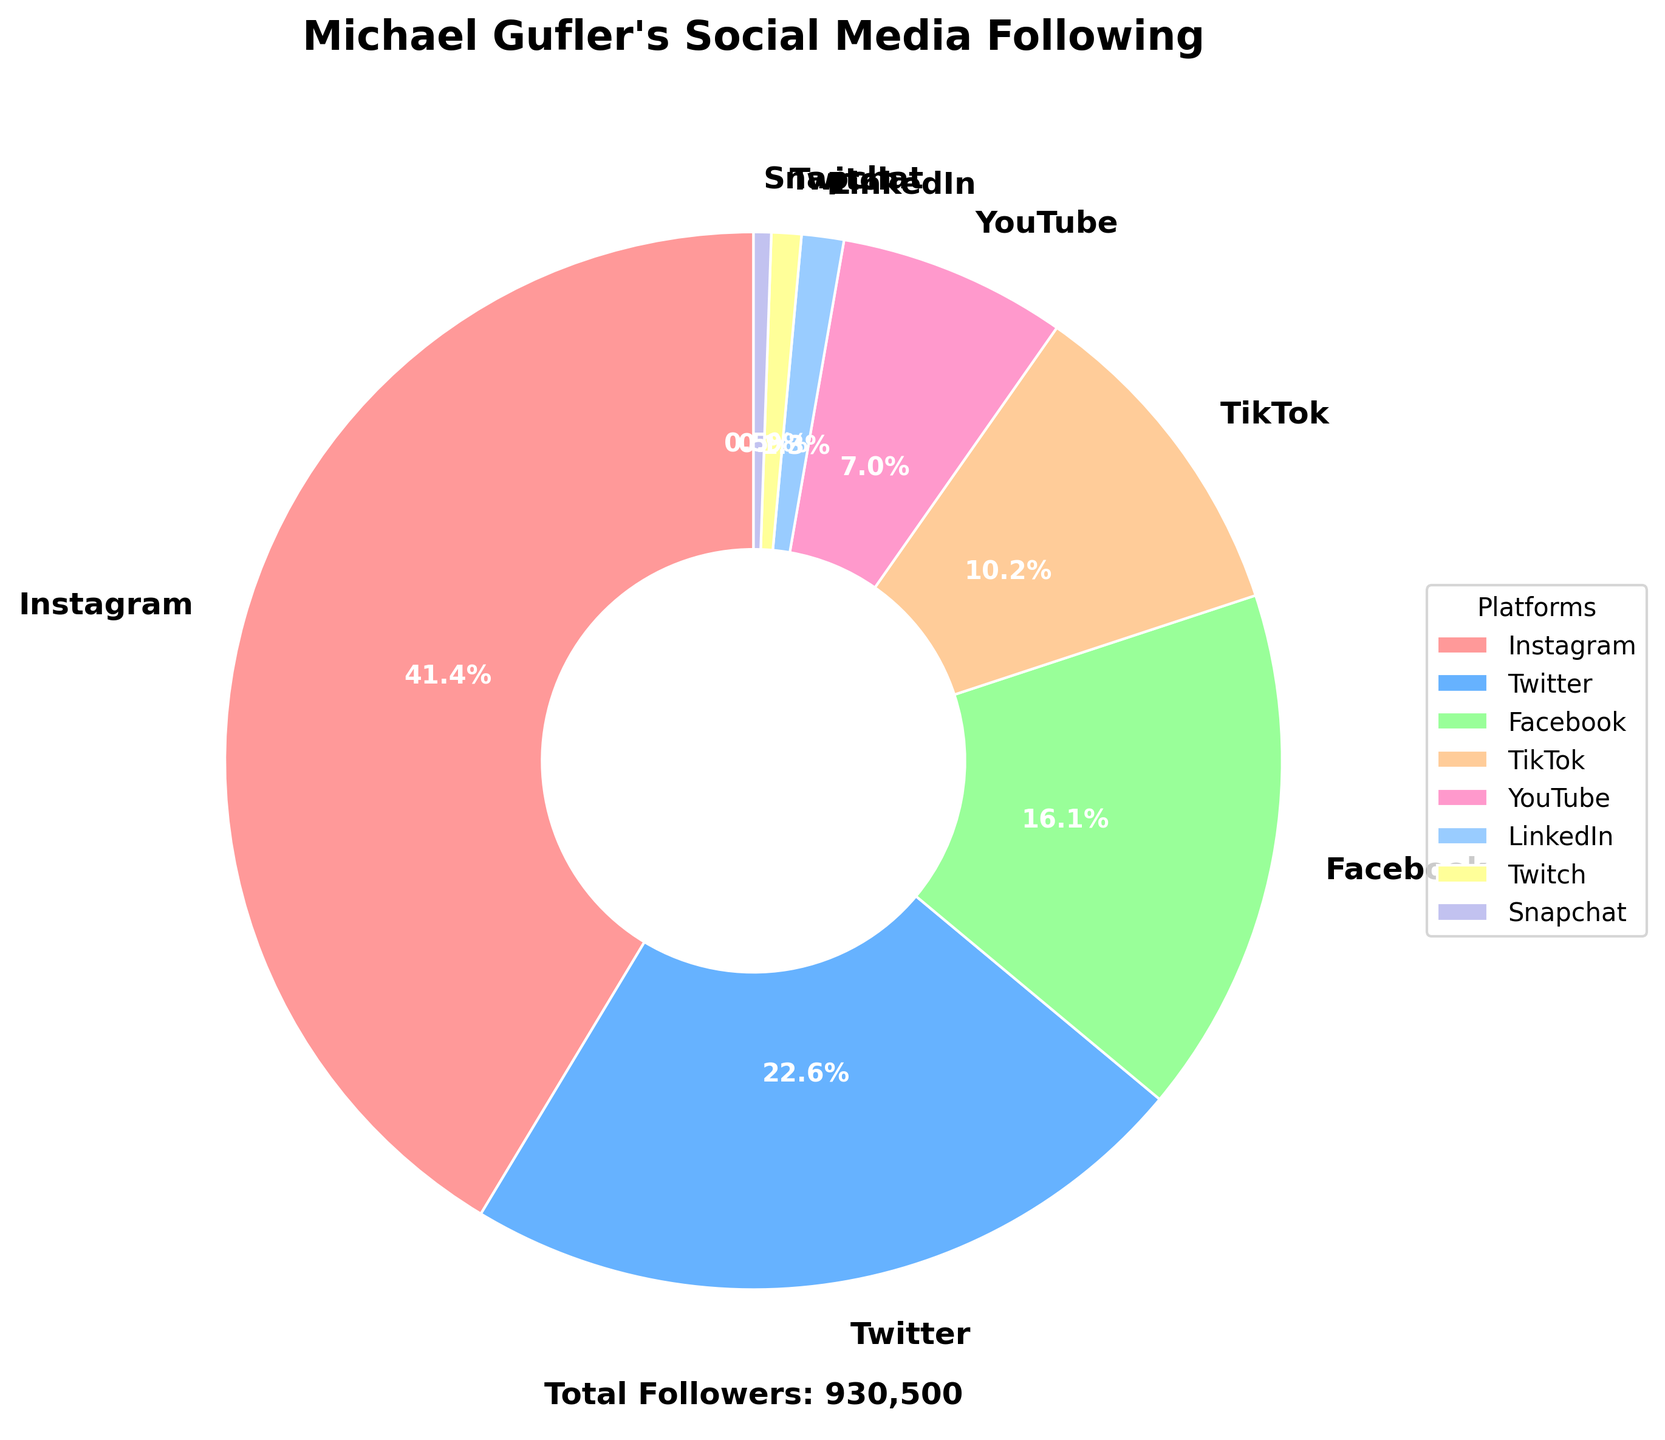Which platform has the highest number of followers? By looking at the pie chart, we can identify the platform with the largest wedge, which represents the highest number of followers. Instagram has the largest share.
Answer: Instagram What percentage of Michael Gufler's following is on TikTok? Find the wedge labeled 'TikTok' in the pie chart and read the percentage value provided inside or next to that wedge.
Answer: 11.4% How many more followers does Michael Gufler have on Instagram compared to Facebook? Subtract Facebook's followers from Instagram's followers to find the difference. 385,000 (Instagram) - 150,000 (Facebook) = 235,000
Answer: 235,000 Which social media platform has the smallest following? Identify the platform with the smallest wedge in the pie chart. Snapchat has the smallest wedge.
Answer: Snapchat What is the combined percentage of followers on YouTube and LinkedIn? Add the percentage values for YouTube and LinkedIn from the pie chart. 6.5% (YouTube) + 1.2% (LinkedIn) = 7.7%
Answer: 7.7% Is Michael Gufler's following on Twitter greater than his following on TikTok? Compare the pie chart wedges for Twitter and TikTok. The wedge for Twitter is larger.
Answer: Yes How does the following on Facebook compare to that on LinkedIn? Look at both wedges in the pie chart and compare their sizes; Facebook's wedge is much larger.
Answer: Facebook is much larger Which social media platform represents about 2.4% of Michael’s followers? Find the wedge in the pie chart labeled 'Twitch,' which represents 2.4% of the total following.
Answer: Twitch After Instagram, which platform has the second largest following? Identify the second largest wedge in the pie chart, which belongs to Twitter.
Answer: Twitter What visual feature represents the total number of followers? The text located slightly below the pie chart provides the total number of followers.
Answer: Text near the pie chart 